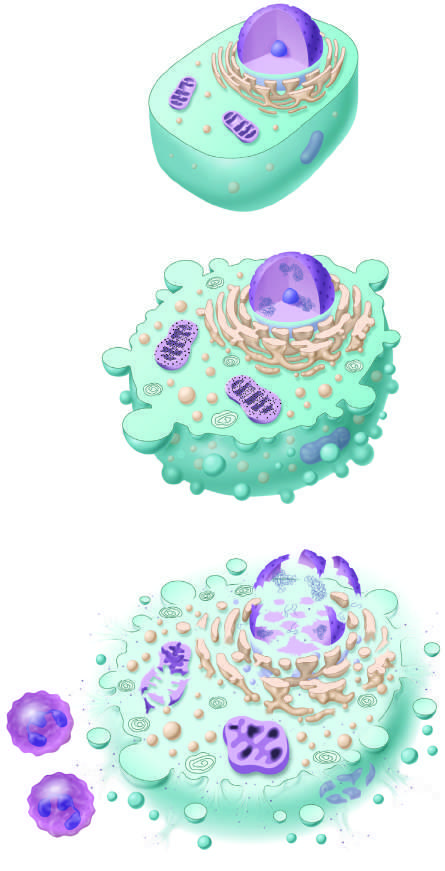how is reversible injury considered to do if the injurious stimulus is not removed, by convention?
Answer the question using a single word or phrase. Culminate in necrosis 